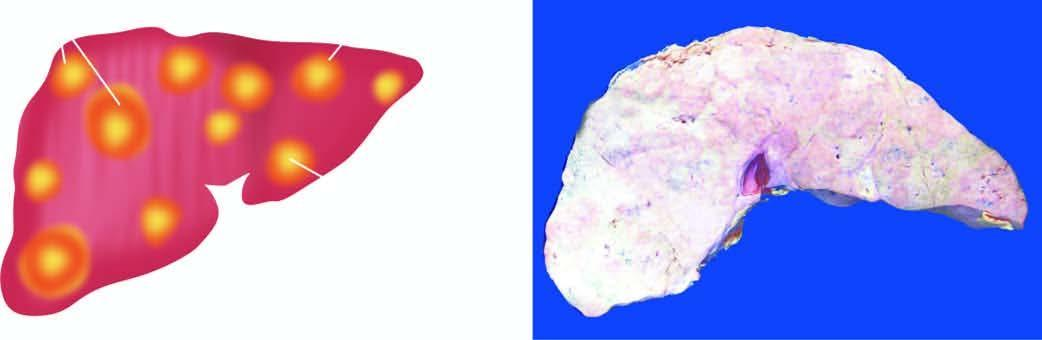s the vascular spaces seen on sectioned surface?
Answer the question using a single word or phrase. No 